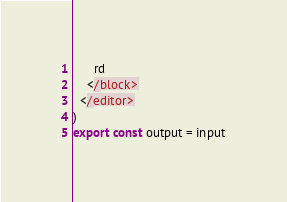<code> <loc_0><loc_0><loc_500><loc_500><_TypeScript_>      rd
    </block>
  </editor>
)
export const output = input
</code> 